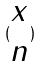Convert formula to latex. <formula><loc_0><loc_0><loc_500><loc_500>( \begin{matrix} x \\ n \end{matrix} )</formula> 